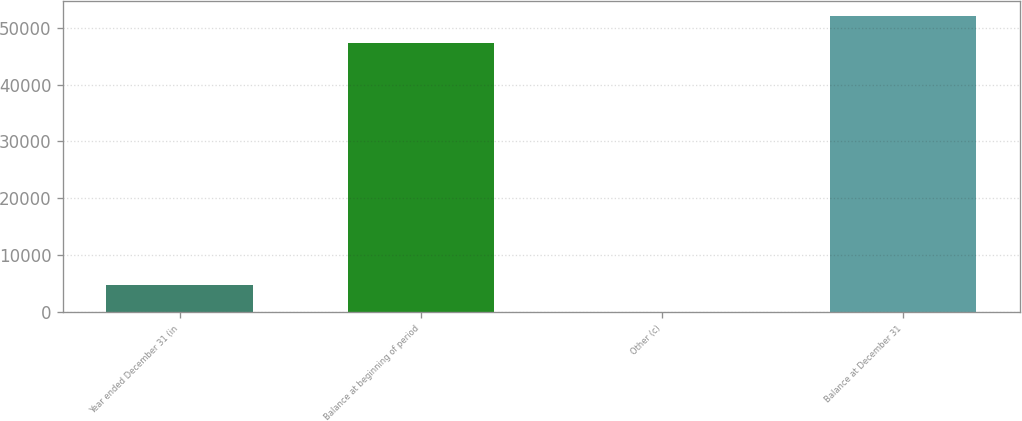Convert chart to OTSL. <chart><loc_0><loc_0><loc_500><loc_500><bar_chart><fcel>Year ended December 31 (in<fcel>Balance at beginning of period<fcel>Other (c)<fcel>Balance at December 31<nl><fcel>4768.7<fcel>47288<fcel>20<fcel>52036.7<nl></chart> 